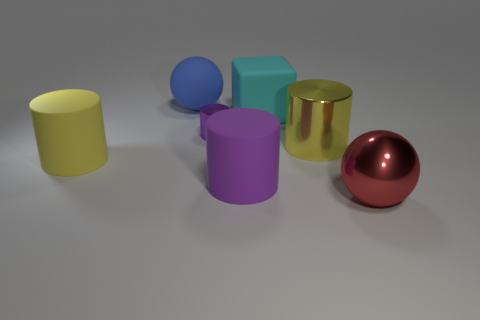Add 3 tiny gray metallic cubes. How many objects exist? 10 Subtract 1 cylinders. How many cylinders are left? 3 Subtract all small cylinders. How many cylinders are left? 3 Subtract all cylinders. How many objects are left? 3 Subtract all blue spheres. How many spheres are left? 1 Subtract all purple metallic things. Subtract all big cylinders. How many objects are left? 3 Add 4 yellow metal cylinders. How many yellow metal cylinders are left? 5 Add 5 rubber things. How many rubber things exist? 9 Subtract 0 brown cylinders. How many objects are left? 7 Subtract all red balls. Subtract all blue cylinders. How many balls are left? 1 